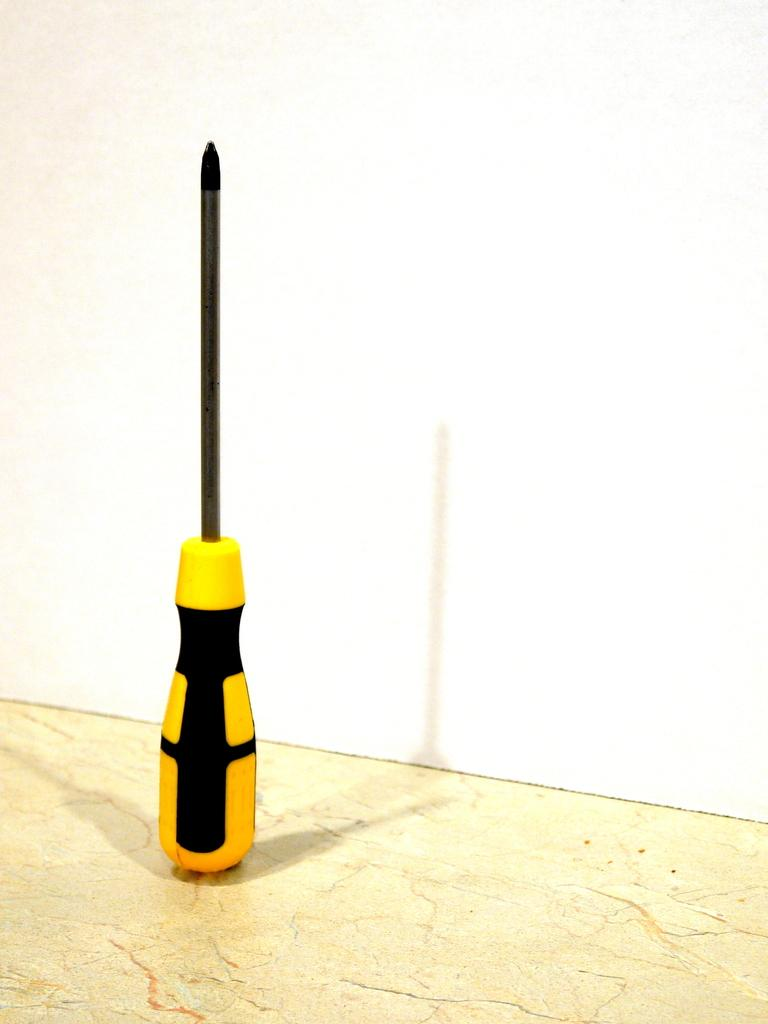What tool is present in the image? There is a screwdriver in the image. What colors can be seen on the screwdriver? The screwdriver is yellow and black in color. What type of reward is being offered in the image? There is no reward being offered in the image; it only features a yellow and black screwdriver. 